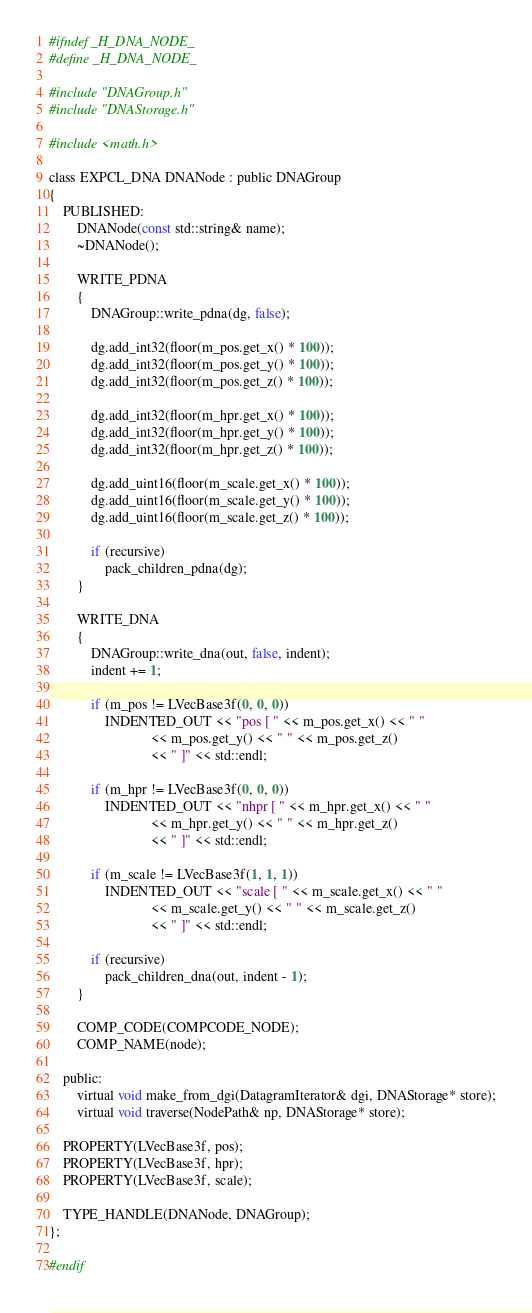<code> <loc_0><loc_0><loc_500><loc_500><_C_>#ifndef _H_DNA_NODE_
#define _H_DNA_NODE_

#include "DNAGroup.h"
#include "DNAStorage.h"

#include <math.h>

class EXPCL_DNA DNANode : public DNAGroup
{
    PUBLISHED:
        DNANode(const std::string& name);
        ~DNANode();
        
        WRITE_PDNA
        {
            DNAGroup::write_pdna(dg, false);
            
            dg.add_int32(floor(m_pos.get_x() * 100));
            dg.add_int32(floor(m_pos.get_y() * 100));
            dg.add_int32(floor(m_pos.get_z() * 100));
            
            dg.add_int32(floor(m_hpr.get_x() * 100));
            dg.add_int32(floor(m_hpr.get_y() * 100));
            dg.add_int32(floor(m_hpr.get_z() * 100));
            
            dg.add_uint16(floor(m_scale.get_x() * 100));
            dg.add_uint16(floor(m_scale.get_y() * 100));
            dg.add_uint16(floor(m_scale.get_z() * 100));
            
            if (recursive)
                pack_children_pdna(dg);
        }
        
        WRITE_DNA
        {
            DNAGroup::write_dna(out, false, indent);
            indent += 1;
            
            if (m_pos != LVecBase3f(0, 0, 0))
                INDENTED_OUT << "pos [ " << m_pos.get_x() << " "
                             << m_pos.get_y() << " " << m_pos.get_z()
                             << " ]" << std::endl;
                             
            if (m_hpr != LVecBase3f(0, 0, 0))
                INDENTED_OUT << "nhpr [ " << m_hpr.get_x() << " "
                             << m_hpr.get_y() << " " << m_hpr.get_z()
                             << " ]" << std::endl;
                             
            if (m_scale != LVecBase3f(1, 1, 1))
                INDENTED_OUT << "scale [ " << m_scale.get_x() << " "
                             << m_scale.get_y() << " " << m_scale.get_z()
                             << " ]" << std::endl;
            
            if (recursive)
                pack_children_dna(out, indent - 1);
        }
        
        COMP_CODE(COMPCODE_NODE);
        COMP_NAME(node);
        
    public:
        virtual void make_from_dgi(DatagramIterator& dgi, DNAStorage* store);
        virtual void traverse(NodePath& np, DNAStorage* store);
        
    PROPERTY(LVecBase3f, pos);
    PROPERTY(LVecBase3f, hpr);
    PROPERTY(LVecBase3f, scale);
    
    TYPE_HANDLE(DNANode, DNAGroup);
};

#endif
</code> 